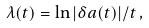Convert formula to latex. <formula><loc_0><loc_0><loc_500><loc_500>\lambda ( t ) = \ln | \delta { a } ( t ) | / t \, ,</formula> 